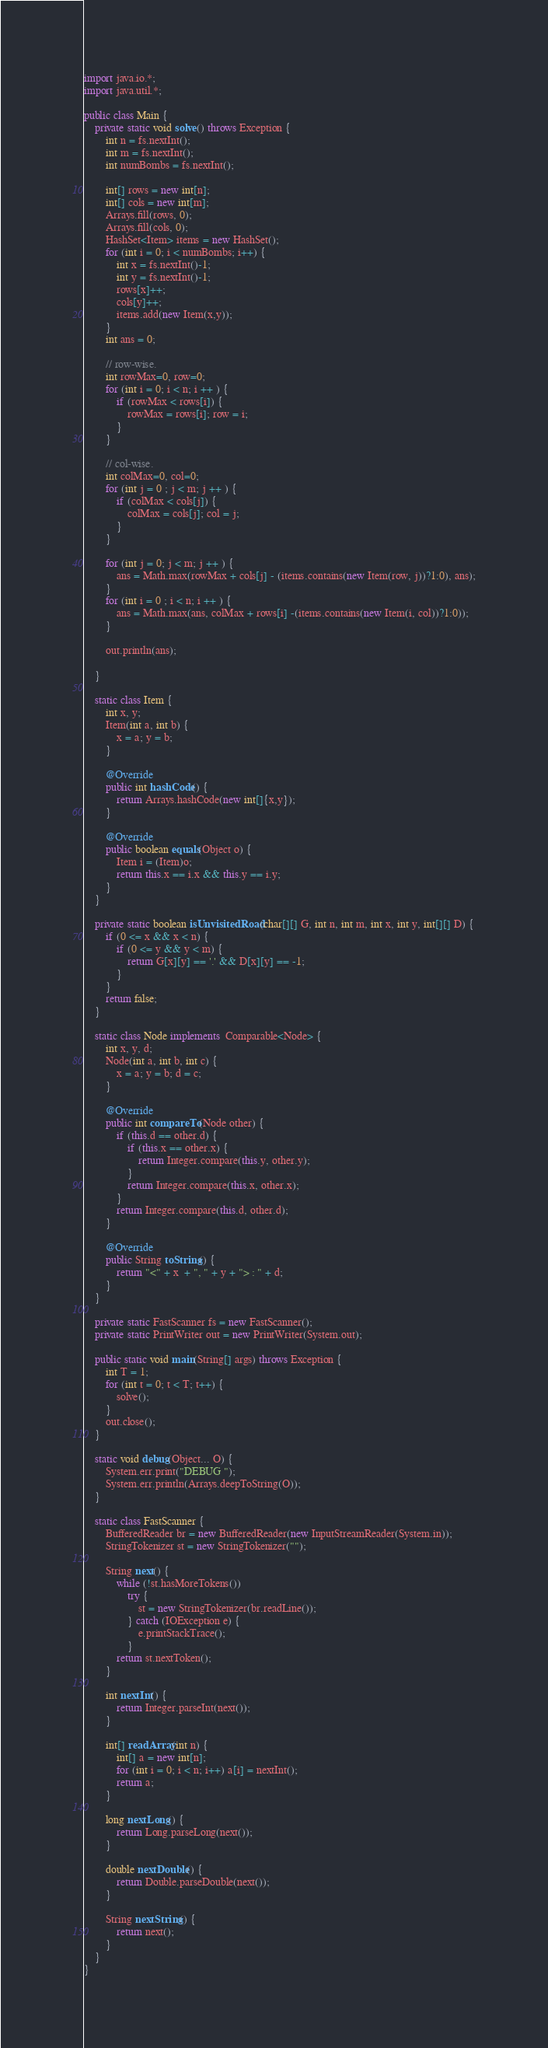Convert code to text. <code><loc_0><loc_0><loc_500><loc_500><_Java_>import java.io.*;
import java.util.*;

public class Main {
    private static void solve() throws Exception {
        int n = fs.nextInt();
        int m = fs.nextInt();
        int numBombs = fs.nextInt();

        int[] rows = new int[n];
        int[] cols = new int[m];
        Arrays.fill(rows, 0);
        Arrays.fill(cols, 0);
        HashSet<Item> items = new HashSet();
        for (int i = 0; i < numBombs; i++) {
            int x = fs.nextInt()-1;
            int y = fs.nextInt()-1;
            rows[x]++;
            cols[y]++;
            items.add(new Item(x,y));
        }
        int ans = 0;

        // row-wise.
        int rowMax=0, row=0;
        for (int i = 0; i < n; i ++ ) {
            if (rowMax < rows[i]) {
                rowMax = rows[i]; row = i;
            }
        }

        // col-wise.
        int colMax=0, col=0;
        for (int j = 0 ; j < m; j ++ ) {
            if (colMax < cols[j]) {
                colMax = cols[j]; col = j;
            }
        }

        for (int j = 0; j < m; j ++ ) {
            ans = Math.max(rowMax + cols[j] - (items.contains(new Item(row, j))?1:0), ans);
        }
        for (int i = 0 ; i < n; i ++ ) {
            ans = Math.max(ans, colMax + rows[i] -(items.contains(new Item(i, col))?1:0));
        }

        out.println(ans);

    }

    static class Item {
        int x, y;
        Item(int a, int b) {
            x = a; y = b;
        }

        @Override
        public int hashCode() {
            return Arrays.hashCode(new int[]{x,y});
        }

        @Override
        public boolean equals(Object o) {
            Item i = (Item)o;
            return this.x == i.x && this.y == i.y;
        }
    }

    private static boolean isUnvisitedRoad(char[][] G, int n, int m, int x, int y, int[][] D) {
        if (0 <= x && x < n) {
            if (0 <= y && y < m) {
                return G[x][y] == '.' && D[x][y] == -1;
            }
        }
        return false;
    }

    static class Node implements  Comparable<Node> {
        int x, y, d;
        Node(int a, int b, int c) {
            x = a; y = b; d = c;
        }

        @Override
        public int compareTo(Node other) {
            if (this.d == other.d) {
                if (this.x == other.x) {
                    return Integer.compare(this.y, other.y);
                }
                return Integer.compare(this.x, other.x);
            }
            return Integer.compare(this.d, other.d);
        }

        @Override
        public String toString() {
            return "<" + x  + ", " + y + "> : " + d;
        }
    }

    private static FastScanner fs = new FastScanner();
    private static PrintWriter out = new PrintWriter(System.out);

    public static void main(String[] args) throws Exception {
        int T = 1;
        for (int t = 0; t < T; t++) {
            solve();
        }
        out.close();
    }

    static void debug(Object... O) {
        System.err.print("DEBUG ");
        System.err.println(Arrays.deepToString(O));
    }

    static class FastScanner {
        BufferedReader br = new BufferedReader(new InputStreamReader(System.in));
        StringTokenizer st = new StringTokenizer("");

        String next() {
            while (!st.hasMoreTokens())
                try {
                    st = new StringTokenizer(br.readLine());
                } catch (IOException e) {
                    e.printStackTrace();
                }
            return st.nextToken();
        }

        int nextInt() {
            return Integer.parseInt(next());
        }

        int[] readArray(int n) {
            int[] a = new int[n];
            for (int i = 0; i < n; i++) a[i] = nextInt();
            return a;
        }

        long nextLong() {
            return Long.parseLong(next());
        }

        double nextDouble() {
            return Double.parseDouble(next());
        }

        String nextString() {
            return next();
        }
    }
}
</code> 